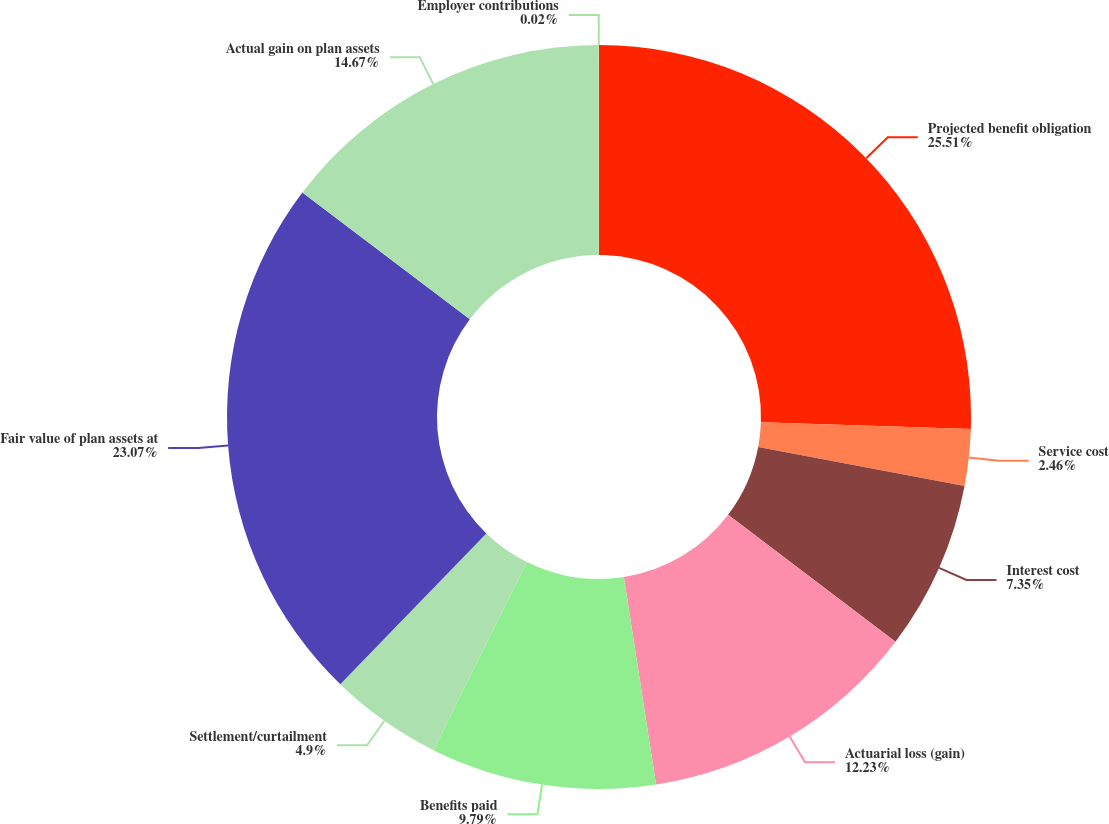<chart> <loc_0><loc_0><loc_500><loc_500><pie_chart><fcel>Projected benefit obligation<fcel>Service cost<fcel>Interest cost<fcel>Actuarial loss (gain)<fcel>Benefits paid<fcel>Settlement/curtailment<fcel>Fair value of plan assets at<fcel>Actual gain on plan assets<fcel>Employer contributions<nl><fcel>25.51%<fcel>2.46%<fcel>7.35%<fcel>12.23%<fcel>9.79%<fcel>4.9%<fcel>23.07%<fcel>14.67%<fcel>0.02%<nl></chart> 